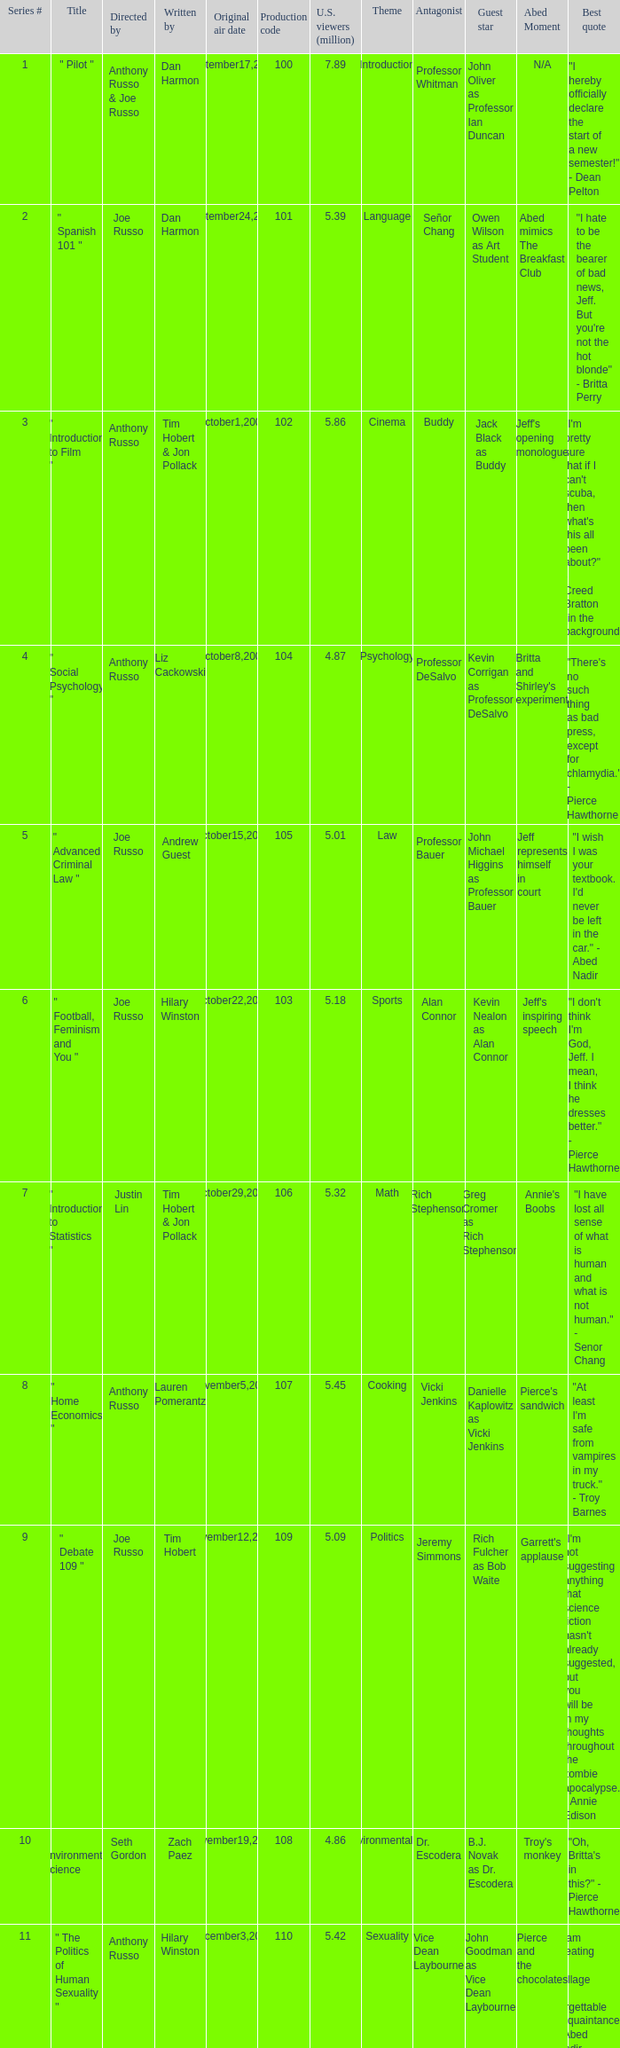What is the highest series # directed by ken whittingham? 18.0. 